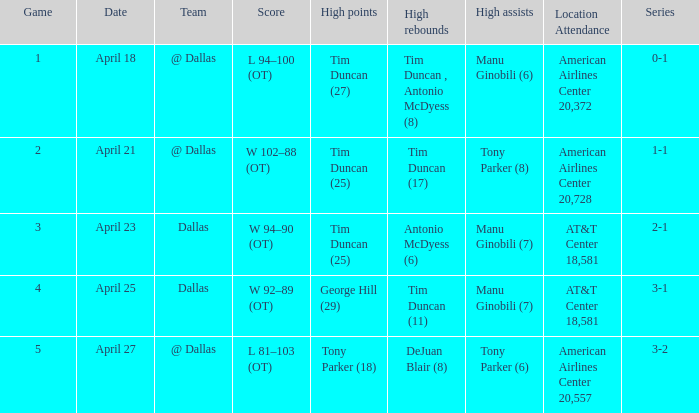Could you help me parse every detail presented in this table? {'header': ['Game', 'Date', 'Team', 'Score', 'High points', 'High rebounds', 'High assists', 'Location Attendance', 'Series'], 'rows': [['1', 'April 18', '@ Dallas', 'L 94–100 (OT)', 'Tim Duncan (27)', 'Tim Duncan , Antonio McDyess (8)', 'Manu Ginobili (6)', 'American Airlines Center 20,372', '0-1'], ['2', 'April 21', '@ Dallas', 'W 102–88 (OT)', 'Tim Duncan (25)', 'Tim Duncan (17)', 'Tony Parker (8)', 'American Airlines Center 20,728', '1-1'], ['3', 'April 23', 'Dallas', 'W 94–90 (OT)', 'Tim Duncan (25)', 'Antonio McDyess (6)', 'Manu Ginobili (7)', 'AT&T Center 18,581', '2-1'], ['4', 'April 25', 'Dallas', 'W 92–89 (OT)', 'George Hill (29)', 'Tim Duncan (11)', 'Manu Ginobili (7)', 'AT&T Center 18,581', '3-1'], ['5', 'April 27', '@ Dallas', 'L 81–103 (OT)', 'Tony Parker (18)', 'DeJuan Blair (8)', 'Tony Parker (6)', 'American Airlines Center 20,557', '3-2']]} When 1-1 is the series who is the team? @ Dallas. 